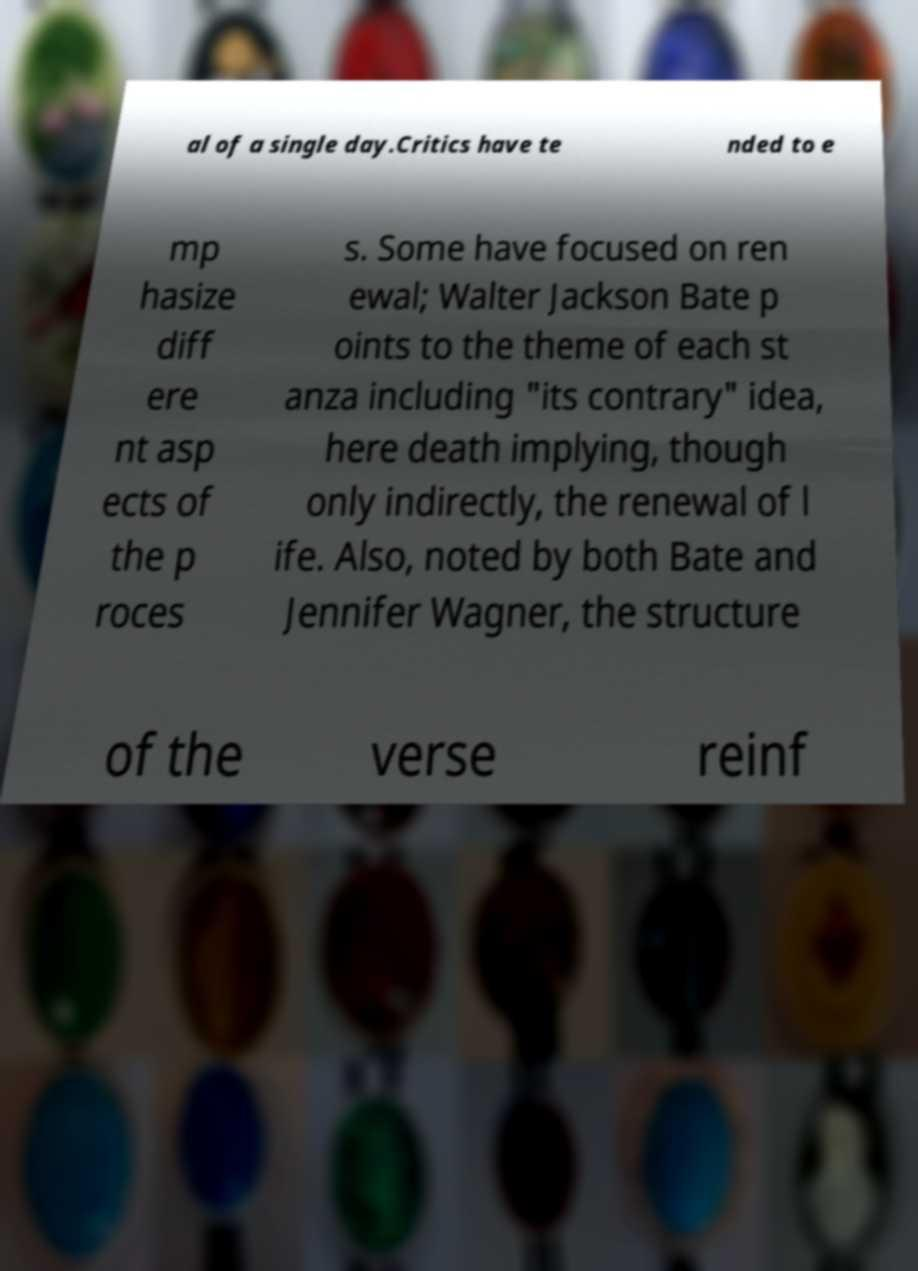There's text embedded in this image that I need extracted. Can you transcribe it verbatim? al of a single day.Critics have te nded to e mp hasize diff ere nt asp ects of the p roces s. Some have focused on ren ewal; Walter Jackson Bate p oints to the theme of each st anza including "its contrary" idea, here death implying, though only indirectly, the renewal of l ife. Also, noted by both Bate and Jennifer Wagner, the structure of the verse reinf 